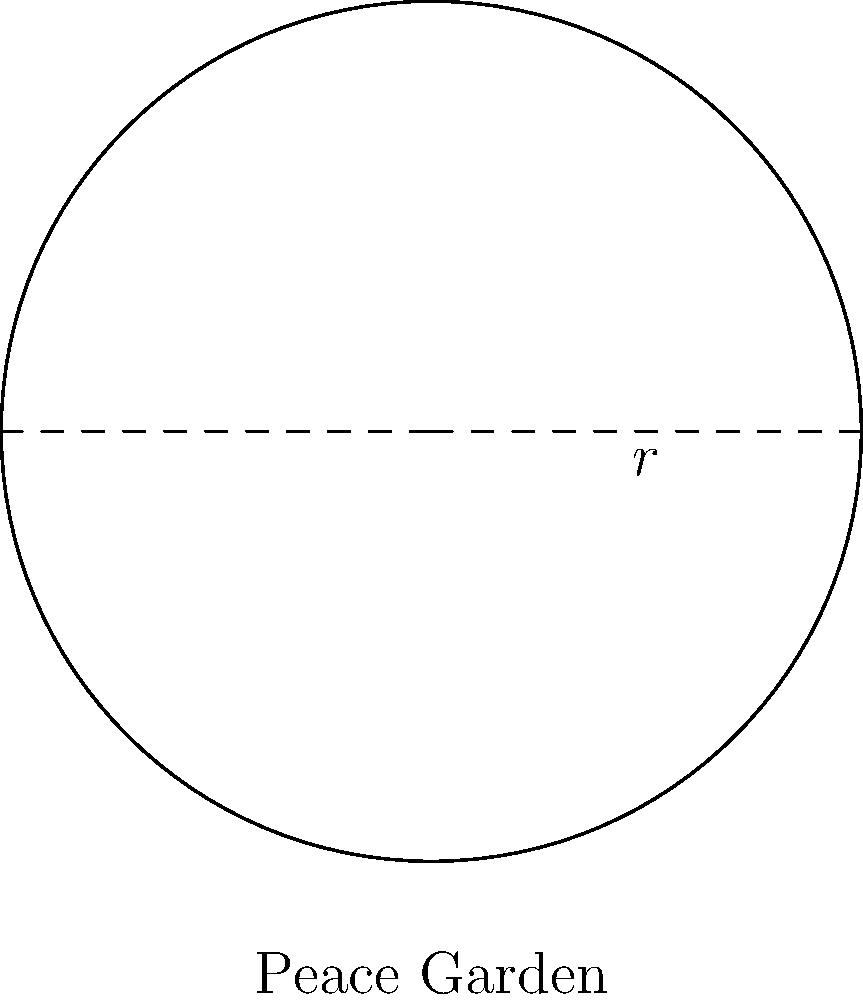A circular peace garden is being designed to promote non-violence in a community center. If the radius of the garden is 10 meters, what is the circumference of the garden to the nearest meter? To find the circumference of a circular garden, we need to follow these steps:

1) The formula for the circumference of a circle is:
   $$C = 2\pi r$$
   where $C$ is the circumference and $r$ is the radius.

2) We are given that the radius is 10 meters.

3) Let's substitute this into our formula:
   $$C = 2\pi (10)$$

4) Simplify:
   $$C = 20\pi$$

5) Now, let's calculate this:
   $$C \approx 20 * 3.14159 \approx 62.8318$$

6) Rounding to the nearest meter:
   $$C \approx 63 \text{ meters}$$

Therefore, the circumference of the peace garden is approximately 63 meters.
Answer: 63 meters 